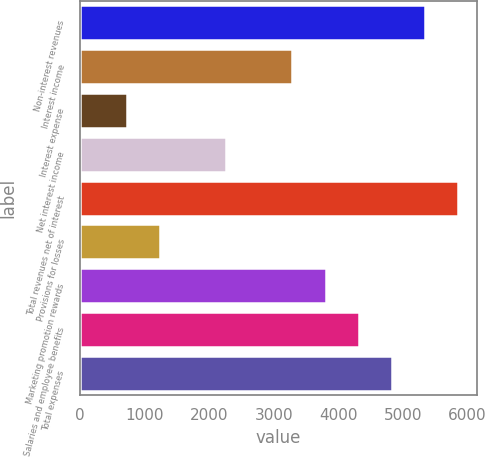<chart> <loc_0><loc_0><loc_500><loc_500><bar_chart><fcel>Non-interest revenues<fcel>Interest income<fcel>Interest expense<fcel>Net interest income<fcel>Total revenues net of interest<fcel>Provisions for losses<fcel>Marketing promotion rewards<fcel>Salaries and employee benefits<fcel>Total expenses<nl><fcel>5337<fcel>3290.2<fcel>731.7<fcel>2266.8<fcel>5848.7<fcel>1243.4<fcel>3801.9<fcel>4313.6<fcel>4825.3<nl></chart> 